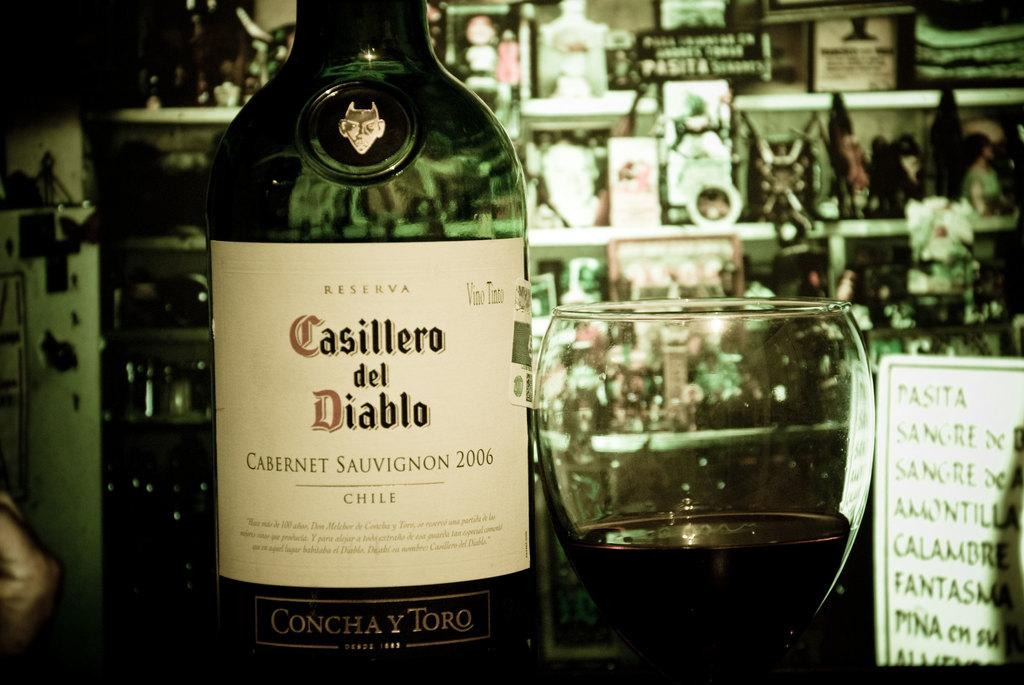<image>
Offer a succinct explanation of the picture presented. a cabernet wine bottle is sitting beside a wine glass of the same 